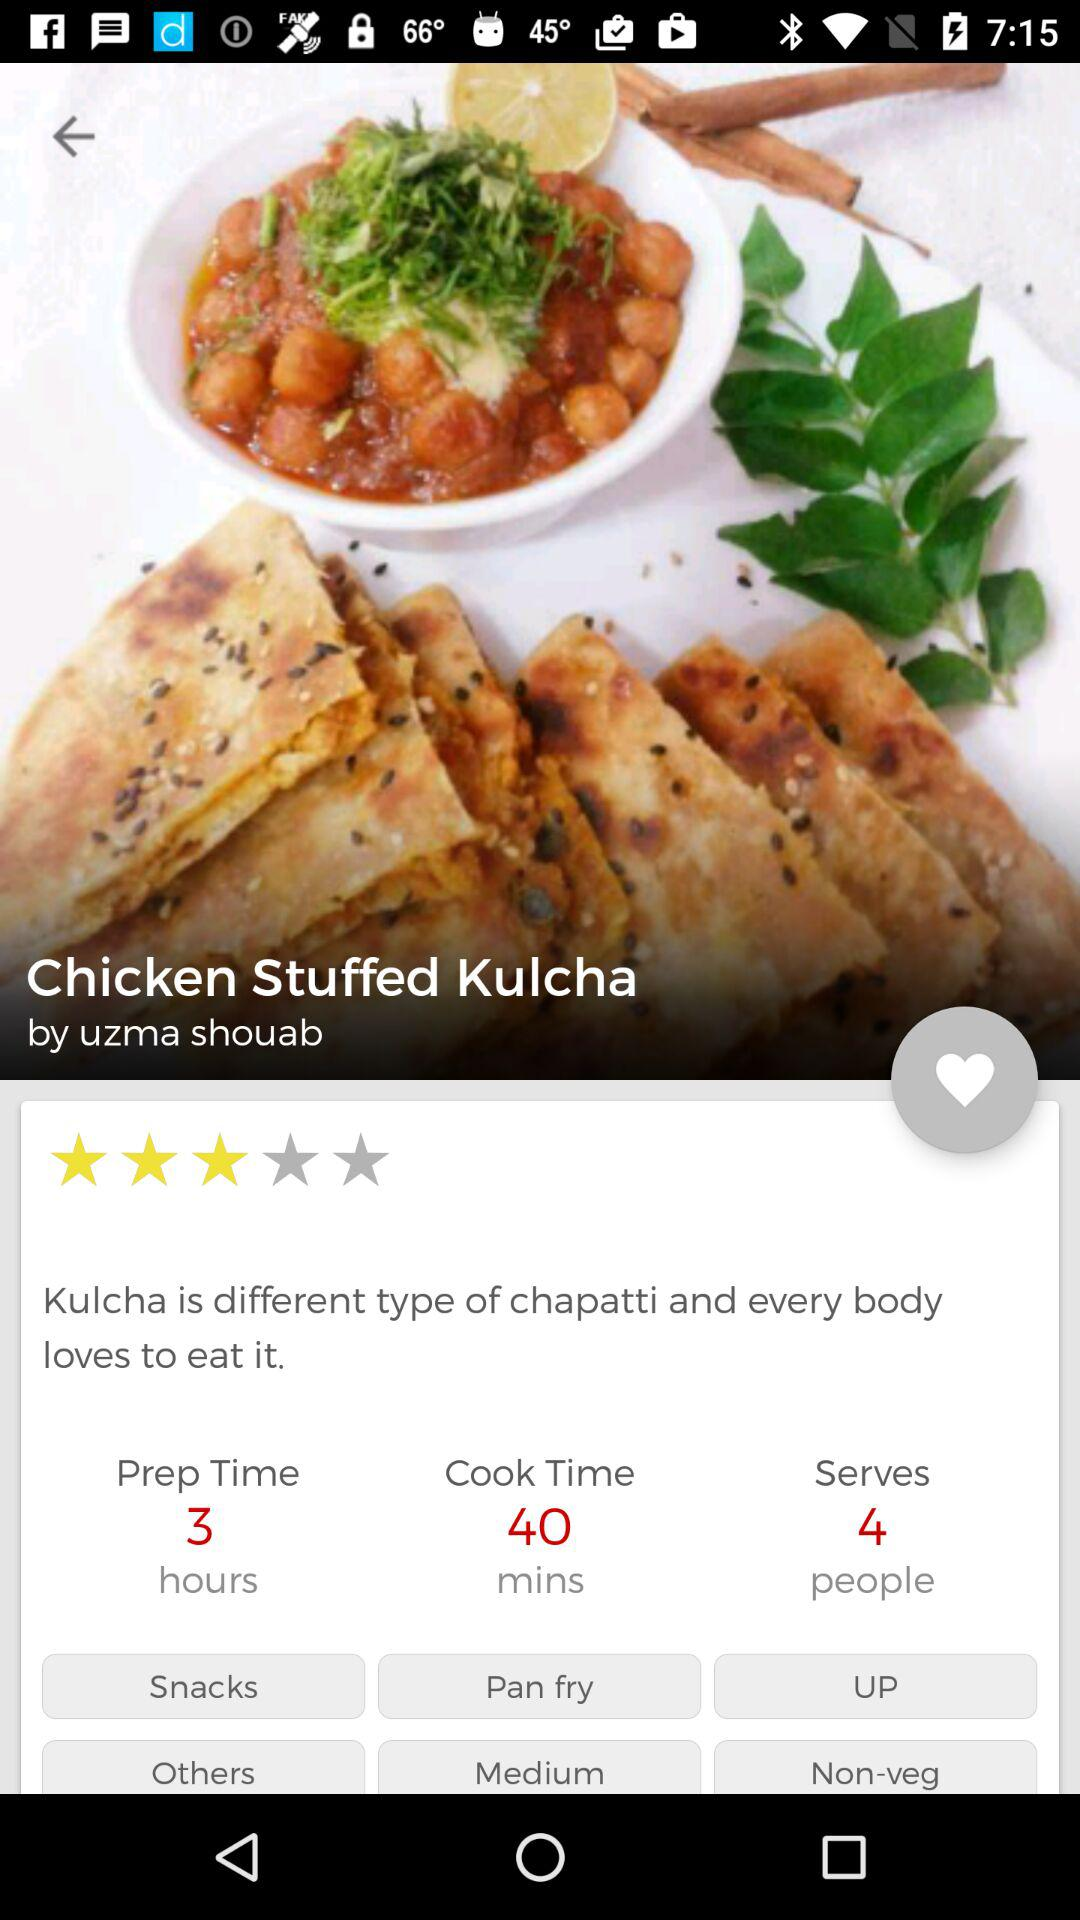Who shared the recipe? The recipe was shared by Uzma Shouab. 